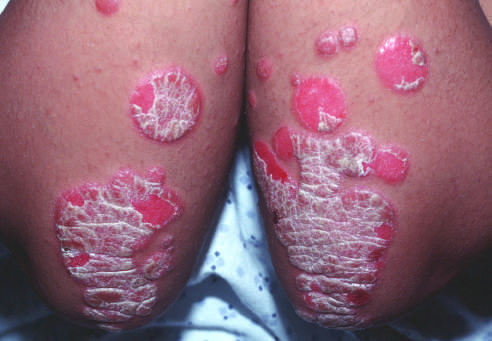how is erythematous psoriatic plaques covered?
Answer the question using a single word or phrase. By silvery-white scale 